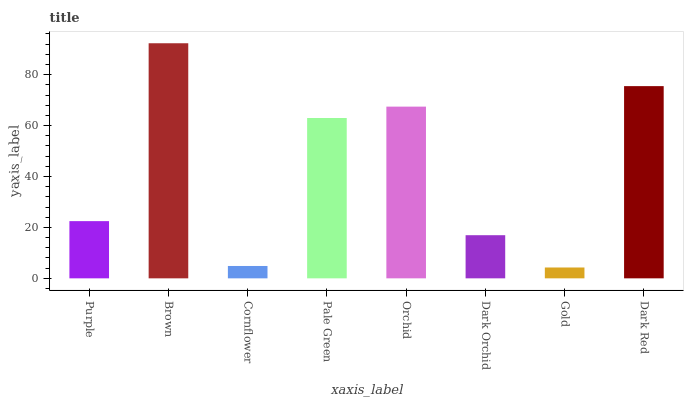Is Gold the minimum?
Answer yes or no. Yes. Is Brown the maximum?
Answer yes or no. Yes. Is Cornflower the minimum?
Answer yes or no. No. Is Cornflower the maximum?
Answer yes or no. No. Is Brown greater than Cornflower?
Answer yes or no. Yes. Is Cornflower less than Brown?
Answer yes or no. Yes. Is Cornflower greater than Brown?
Answer yes or no. No. Is Brown less than Cornflower?
Answer yes or no. No. Is Pale Green the high median?
Answer yes or no. Yes. Is Purple the low median?
Answer yes or no. Yes. Is Purple the high median?
Answer yes or no. No. Is Orchid the low median?
Answer yes or no. No. 